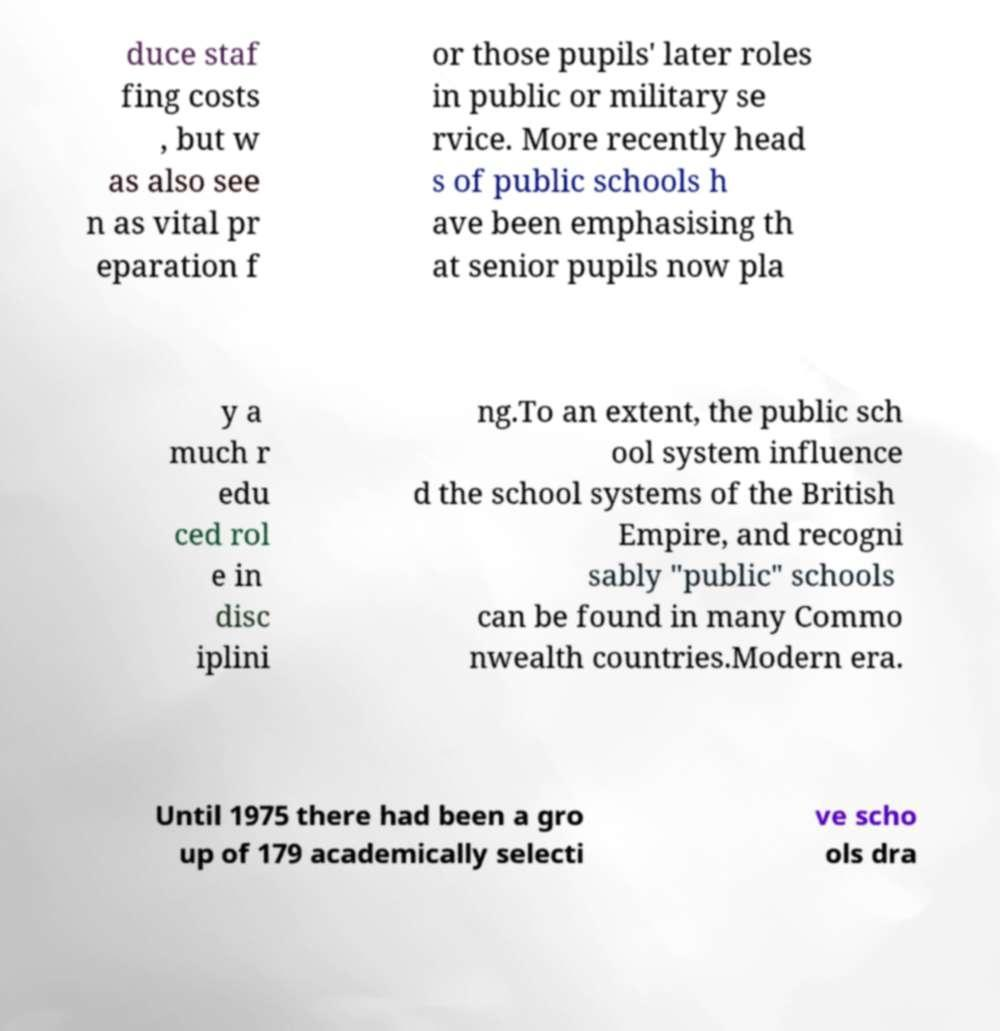Can you accurately transcribe the text from the provided image for me? duce staf fing costs , but w as also see n as vital pr eparation f or those pupils' later roles in public or military se rvice. More recently head s of public schools h ave been emphasising th at senior pupils now pla y a much r edu ced rol e in disc iplini ng.To an extent, the public sch ool system influence d the school systems of the British Empire, and recogni sably "public" schools can be found in many Commo nwealth countries.Modern era. Until 1975 there had been a gro up of 179 academically selecti ve scho ols dra 